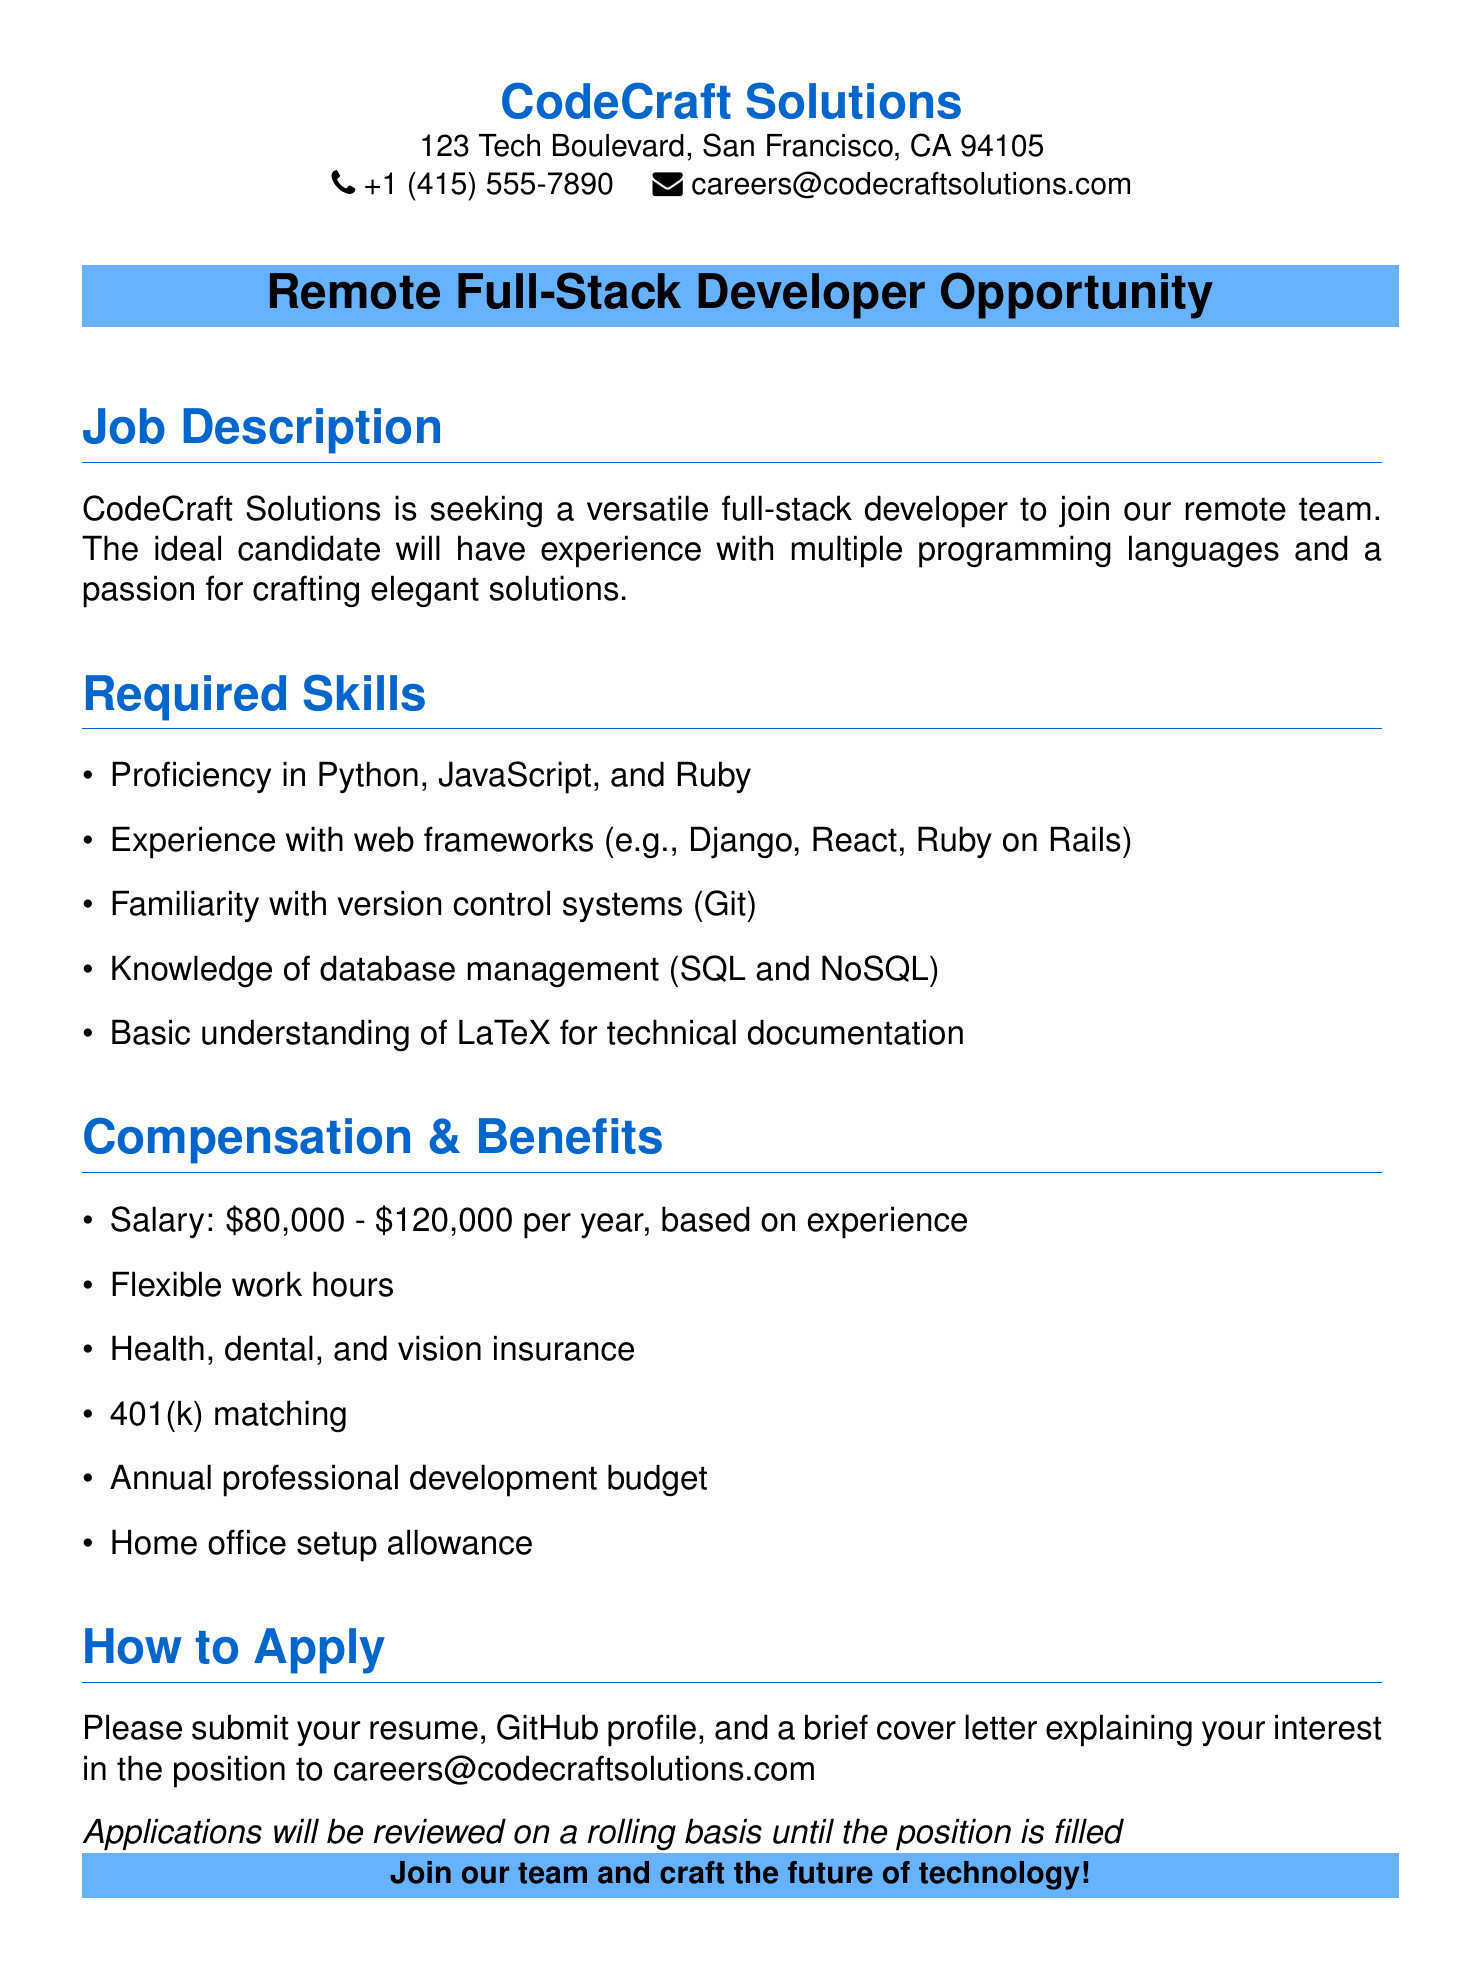What is the job title? The job title is stated at the top of the job description section and is "Remote Full-Stack Developer Opportunity".
Answer: Remote Full-Stack Developer Opportunity What is the salary range? The salary range is mentioned in the compensation section and is from $80,000 to $120,000 per year, based on experience.
Answer: $80,000 - $120,000 Which programming languages are required? The required programming languages are listed in the required skills section and include Python, JavaScript, and Ruby.
Answer: Python, JavaScript, Ruby What type of insurance is offered? The types of insurance are detailed in the compensation section and include health, dental, and vision insurance.
Answer: Health, dental, and vision insurance How should applicants apply? The application method is specified in the how to apply section, which states that applicants should submit their resume, GitHub profile, and a brief cover letter.
Answer: Submit your resume, GitHub profile, and a brief cover letter What is the minimum experience required for the job? The document notes the salary is based on experience, implying that some experience is required without stating a minimum; hence the answer indicates it's not specified.
Answer: Not specified What is one benefit related to professional development? The compensation section lists an annual professional development budget as one of the benefits.
Answer: Annual professional development budget What is the main company’s name? The company's name is prominently displayed at the top of the document.
Answer: CodeCraft Solutions 